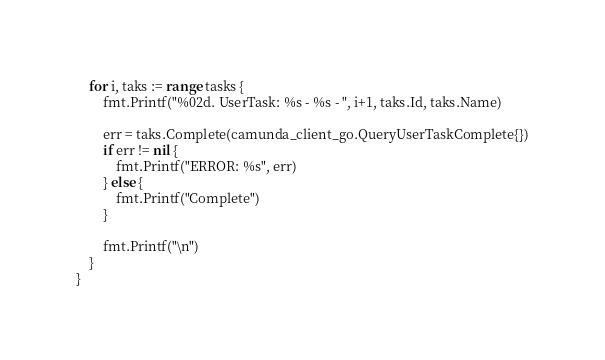<code> <loc_0><loc_0><loc_500><loc_500><_Go_>	for i, taks := range tasks {
		fmt.Printf("%02d. UserTask: %s - %s - ", i+1, taks.Id, taks.Name)

		err = taks.Complete(camunda_client_go.QueryUserTaskComplete{})
		if err != nil {
			fmt.Printf("ERROR: %s", err)
		} else {
			fmt.Printf("Complete")
		}

		fmt.Printf("\n")
	}
}
</code> 